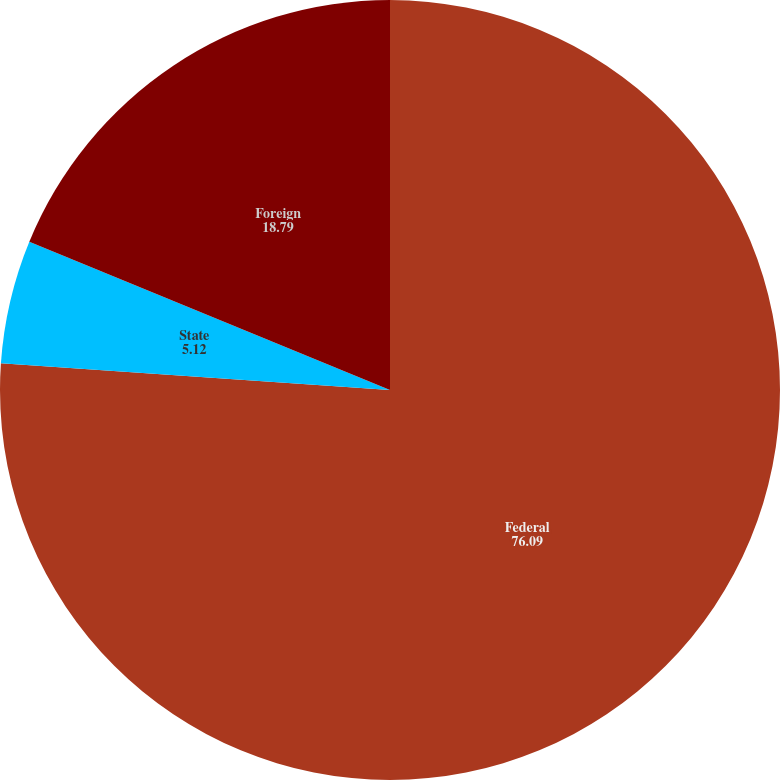Convert chart to OTSL. <chart><loc_0><loc_0><loc_500><loc_500><pie_chart><fcel>Federal<fcel>State<fcel>Foreign<nl><fcel>76.09%<fcel>5.12%<fcel>18.79%<nl></chart> 